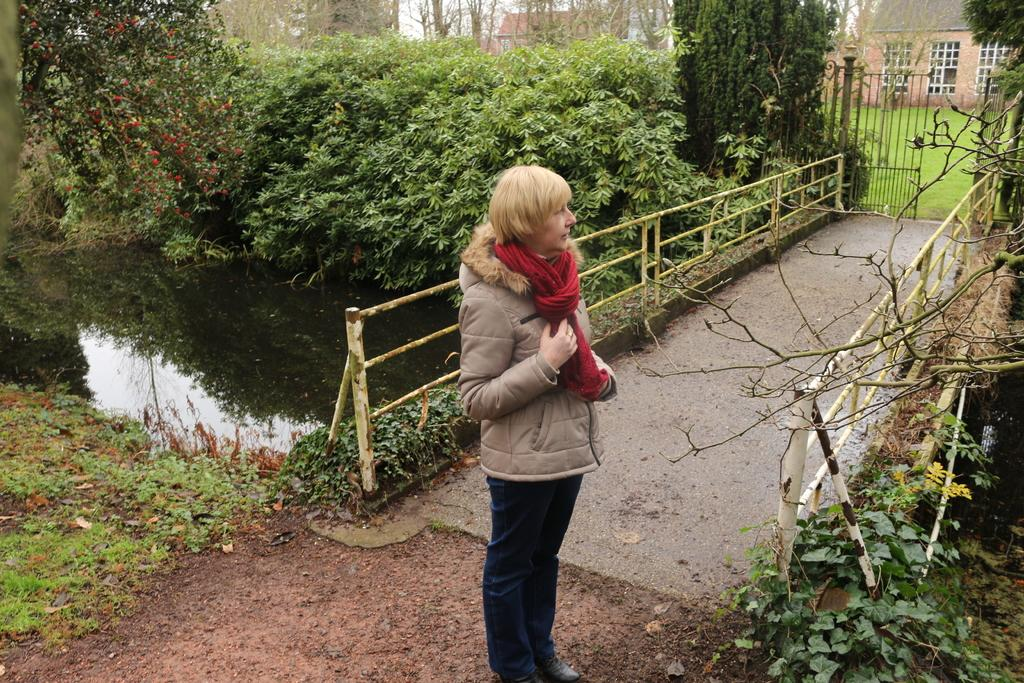What is the main subject in the center of the image? There is a person standing in the center of the image. What can be seen on the left side of the image? There is a canal on the left side of the image. What is present over the canal? There is a bridge over the canal. What can be seen in the background of the image? There is a gate visible in the background, along with buildings and trees. How does the person in the image interact with the railway? There is no railway present in the image; it features a canal, bridge, and other elements. 